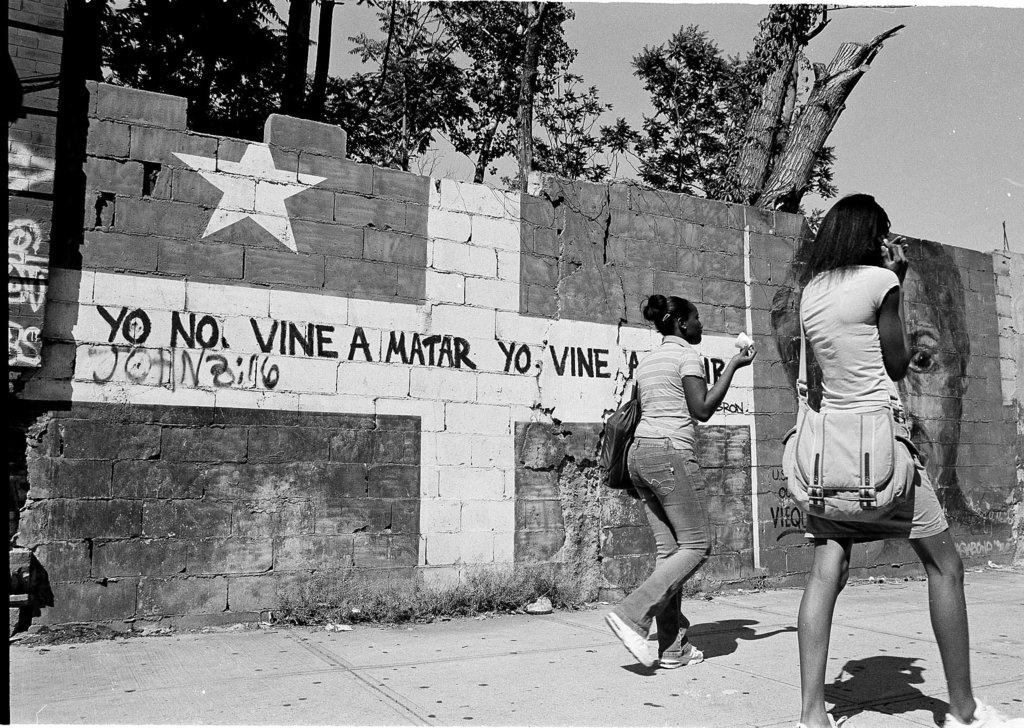How many people are in the image? There are two girls in the image. Where are the girls located in the image? The girls are on the right side of the image. What is in the center of the image? There is a wall in the center of the image. What type of vegetation can be seen at the top side of the image? There are trees at the top side of the image. What year is the ghost from in the image? There is no ghost present in the image. On which side of the image is the side table located? There is no side table mentioned in the provided facts, so it cannot be determined from the image. 